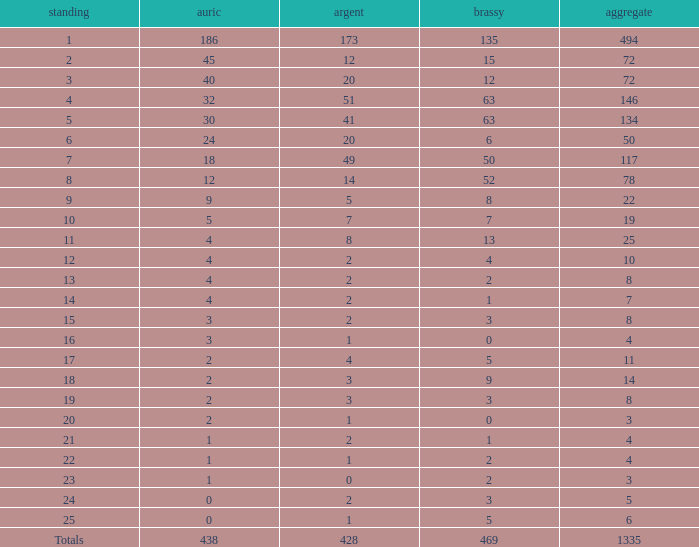What is the number of bronze medals when the total medals were 78 and there were less than 12 golds? None. 